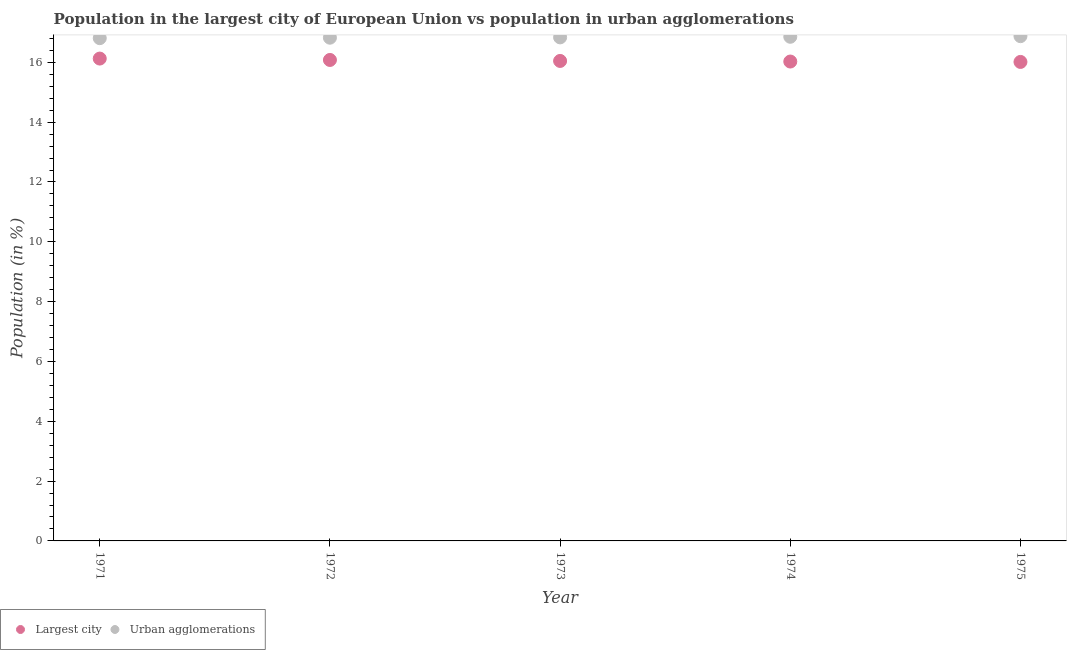How many different coloured dotlines are there?
Your answer should be compact. 2. Is the number of dotlines equal to the number of legend labels?
Offer a terse response. Yes. What is the population in the largest city in 1974?
Ensure brevity in your answer.  16.03. Across all years, what is the maximum population in urban agglomerations?
Offer a terse response. 16.88. Across all years, what is the minimum population in urban agglomerations?
Your answer should be compact. 16.81. In which year was the population in urban agglomerations maximum?
Your response must be concise. 1975. In which year was the population in the largest city minimum?
Ensure brevity in your answer.  1975. What is the total population in urban agglomerations in the graph?
Your answer should be compact. 84.2. What is the difference between the population in urban agglomerations in 1972 and that in 1975?
Your answer should be compact. -0.05. What is the difference between the population in urban agglomerations in 1975 and the population in the largest city in 1973?
Offer a terse response. 0.83. What is the average population in urban agglomerations per year?
Your answer should be compact. 16.84. In the year 1972, what is the difference between the population in the largest city and population in urban agglomerations?
Provide a short and direct response. -0.74. What is the ratio of the population in the largest city in 1974 to that in 1975?
Provide a short and direct response. 1. Is the population in the largest city in 1971 less than that in 1973?
Make the answer very short. No. What is the difference between the highest and the second highest population in the largest city?
Offer a terse response. 0.05. What is the difference between the highest and the lowest population in the largest city?
Ensure brevity in your answer.  0.11. In how many years, is the population in urban agglomerations greater than the average population in urban agglomerations taken over all years?
Provide a short and direct response. 2. Is the population in the largest city strictly greater than the population in urban agglomerations over the years?
Your answer should be compact. No. How many years are there in the graph?
Your answer should be very brief. 5. What is the difference between two consecutive major ticks on the Y-axis?
Provide a short and direct response. 2. Does the graph contain grids?
Offer a very short reply. No. How many legend labels are there?
Your answer should be very brief. 2. How are the legend labels stacked?
Your response must be concise. Horizontal. What is the title of the graph?
Your response must be concise. Population in the largest city of European Union vs population in urban agglomerations. What is the Population (in %) in Largest city in 1971?
Offer a very short reply. 16.13. What is the Population (in %) of Urban agglomerations in 1971?
Your answer should be very brief. 16.81. What is the Population (in %) in Largest city in 1972?
Offer a very short reply. 16.08. What is the Population (in %) in Urban agglomerations in 1972?
Give a very brief answer. 16.82. What is the Population (in %) in Largest city in 1973?
Make the answer very short. 16.05. What is the Population (in %) of Urban agglomerations in 1973?
Give a very brief answer. 16.84. What is the Population (in %) of Largest city in 1974?
Provide a succinct answer. 16.03. What is the Population (in %) of Urban agglomerations in 1974?
Offer a very short reply. 16.86. What is the Population (in %) of Largest city in 1975?
Give a very brief answer. 16.01. What is the Population (in %) in Urban agglomerations in 1975?
Offer a terse response. 16.88. Across all years, what is the maximum Population (in %) in Largest city?
Provide a succinct answer. 16.13. Across all years, what is the maximum Population (in %) of Urban agglomerations?
Give a very brief answer. 16.88. Across all years, what is the minimum Population (in %) in Largest city?
Your response must be concise. 16.01. Across all years, what is the minimum Population (in %) in Urban agglomerations?
Keep it short and to the point. 16.81. What is the total Population (in %) in Largest city in the graph?
Provide a succinct answer. 80.3. What is the total Population (in %) in Urban agglomerations in the graph?
Provide a succinct answer. 84.2. What is the difference between the Population (in %) of Largest city in 1971 and that in 1972?
Your response must be concise. 0.05. What is the difference between the Population (in %) of Urban agglomerations in 1971 and that in 1972?
Ensure brevity in your answer.  -0.02. What is the difference between the Population (in %) in Largest city in 1971 and that in 1973?
Ensure brevity in your answer.  0.08. What is the difference between the Population (in %) of Urban agglomerations in 1971 and that in 1973?
Offer a very short reply. -0.03. What is the difference between the Population (in %) in Largest city in 1971 and that in 1974?
Your answer should be compact. 0.1. What is the difference between the Population (in %) of Urban agglomerations in 1971 and that in 1974?
Provide a succinct answer. -0.05. What is the difference between the Population (in %) of Largest city in 1971 and that in 1975?
Make the answer very short. 0.11. What is the difference between the Population (in %) of Urban agglomerations in 1971 and that in 1975?
Offer a very short reply. -0.07. What is the difference between the Population (in %) of Largest city in 1972 and that in 1973?
Make the answer very short. 0.03. What is the difference between the Population (in %) of Urban agglomerations in 1972 and that in 1973?
Provide a succinct answer. -0.01. What is the difference between the Population (in %) of Largest city in 1972 and that in 1974?
Provide a short and direct response. 0.05. What is the difference between the Population (in %) in Urban agglomerations in 1972 and that in 1974?
Provide a short and direct response. -0.03. What is the difference between the Population (in %) of Largest city in 1972 and that in 1975?
Your response must be concise. 0.07. What is the difference between the Population (in %) in Urban agglomerations in 1972 and that in 1975?
Offer a very short reply. -0.05. What is the difference between the Population (in %) in Largest city in 1973 and that in 1974?
Make the answer very short. 0.02. What is the difference between the Population (in %) of Urban agglomerations in 1973 and that in 1974?
Your answer should be compact. -0.02. What is the difference between the Population (in %) of Largest city in 1973 and that in 1975?
Offer a terse response. 0.03. What is the difference between the Population (in %) in Urban agglomerations in 1973 and that in 1975?
Make the answer very short. -0.04. What is the difference between the Population (in %) of Largest city in 1974 and that in 1975?
Offer a terse response. 0.01. What is the difference between the Population (in %) of Urban agglomerations in 1974 and that in 1975?
Offer a terse response. -0.02. What is the difference between the Population (in %) of Largest city in 1971 and the Population (in %) of Urban agglomerations in 1972?
Offer a very short reply. -0.7. What is the difference between the Population (in %) of Largest city in 1971 and the Population (in %) of Urban agglomerations in 1973?
Provide a succinct answer. -0.71. What is the difference between the Population (in %) of Largest city in 1971 and the Population (in %) of Urban agglomerations in 1974?
Keep it short and to the point. -0.73. What is the difference between the Population (in %) in Largest city in 1971 and the Population (in %) in Urban agglomerations in 1975?
Provide a short and direct response. -0.75. What is the difference between the Population (in %) in Largest city in 1972 and the Population (in %) in Urban agglomerations in 1973?
Your answer should be very brief. -0.75. What is the difference between the Population (in %) in Largest city in 1972 and the Population (in %) in Urban agglomerations in 1974?
Provide a succinct answer. -0.77. What is the difference between the Population (in %) in Largest city in 1972 and the Population (in %) in Urban agglomerations in 1975?
Provide a short and direct response. -0.8. What is the difference between the Population (in %) of Largest city in 1973 and the Population (in %) of Urban agglomerations in 1974?
Give a very brief answer. -0.81. What is the difference between the Population (in %) of Largest city in 1973 and the Population (in %) of Urban agglomerations in 1975?
Provide a succinct answer. -0.83. What is the difference between the Population (in %) in Largest city in 1974 and the Population (in %) in Urban agglomerations in 1975?
Make the answer very short. -0.85. What is the average Population (in %) in Largest city per year?
Offer a very short reply. 16.06. What is the average Population (in %) of Urban agglomerations per year?
Keep it short and to the point. 16.84. In the year 1971, what is the difference between the Population (in %) in Largest city and Population (in %) in Urban agglomerations?
Offer a very short reply. -0.68. In the year 1972, what is the difference between the Population (in %) in Largest city and Population (in %) in Urban agglomerations?
Offer a terse response. -0.74. In the year 1973, what is the difference between the Population (in %) in Largest city and Population (in %) in Urban agglomerations?
Ensure brevity in your answer.  -0.79. In the year 1974, what is the difference between the Population (in %) in Largest city and Population (in %) in Urban agglomerations?
Make the answer very short. -0.83. In the year 1975, what is the difference between the Population (in %) of Largest city and Population (in %) of Urban agglomerations?
Your answer should be very brief. -0.86. What is the ratio of the Population (in %) of Largest city in 1971 to that in 1975?
Provide a short and direct response. 1.01. What is the ratio of the Population (in %) in Urban agglomerations in 1971 to that in 1975?
Offer a terse response. 1. What is the ratio of the Population (in %) in Largest city in 1972 to that in 1973?
Your answer should be compact. 1. What is the ratio of the Population (in %) of Urban agglomerations in 1972 to that in 1973?
Your response must be concise. 1. What is the ratio of the Population (in %) of Largest city in 1972 to that in 1974?
Your response must be concise. 1. What is the ratio of the Population (in %) in Urban agglomerations in 1972 to that in 1974?
Make the answer very short. 1. What is the ratio of the Population (in %) in Largest city in 1972 to that in 1975?
Keep it short and to the point. 1. What is the ratio of the Population (in %) of Urban agglomerations in 1972 to that in 1975?
Your answer should be very brief. 1. What is the ratio of the Population (in %) of Urban agglomerations in 1973 to that in 1974?
Your answer should be very brief. 1. What is the ratio of the Population (in %) in Urban agglomerations in 1973 to that in 1975?
Make the answer very short. 1. What is the ratio of the Population (in %) of Largest city in 1974 to that in 1975?
Provide a succinct answer. 1. What is the difference between the highest and the second highest Population (in %) in Largest city?
Give a very brief answer. 0.05. What is the difference between the highest and the second highest Population (in %) of Urban agglomerations?
Your answer should be very brief. 0.02. What is the difference between the highest and the lowest Population (in %) of Largest city?
Give a very brief answer. 0.11. What is the difference between the highest and the lowest Population (in %) of Urban agglomerations?
Your response must be concise. 0.07. 